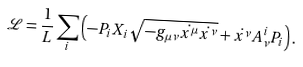Convert formula to latex. <formula><loc_0><loc_0><loc_500><loc_500>\mathcal { L } = \frac { 1 } { L } \sum _ { i } \left ( - P _ { i } X _ { i } \sqrt { - g _ { \mu \nu } \dot { x ^ { \mu } } \dot { x ^ { \nu } } } + \dot { x ^ { \nu } } A _ { \nu } ^ { i } P _ { i } \right ) .</formula> 